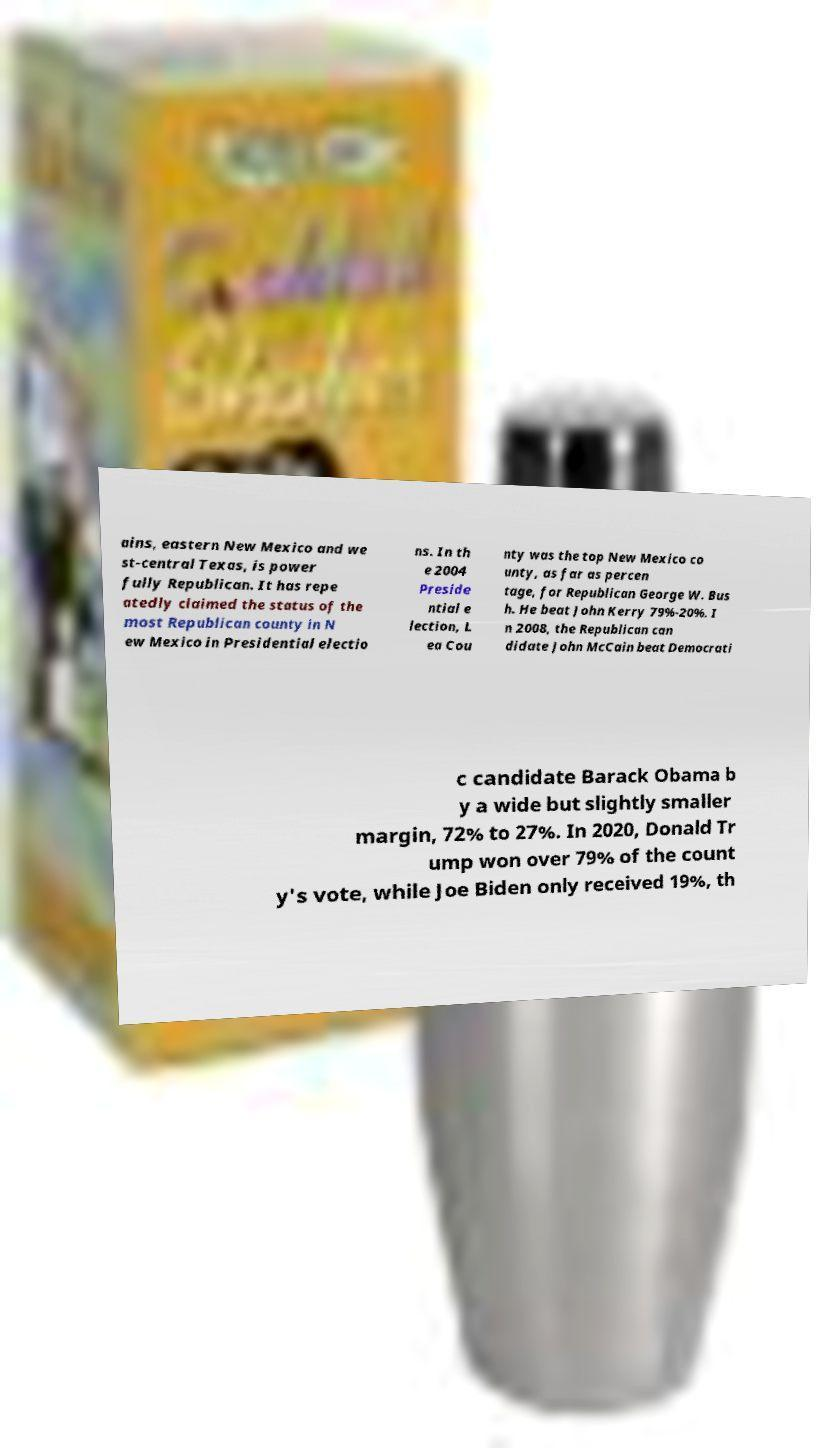Please identify and transcribe the text found in this image. ains, eastern New Mexico and we st-central Texas, is power fully Republican. It has repe atedly claimed the status of the most Republican county in N ew Mexico in Presidential electio ns. In th e 2004 Preside ntial e lection, L ea Cou nty was the top New Mexico co unty, as far as percen tage, for Republican George W. Bus h. He beat John Kerry 79%-20%. I n 2008, the Republican can didate John McCain beat Democrati c candidate Barack Obama b y a wide but slightly smaller margin, 72% to 27%. In 2020, Donald Tr ump won over 79% of the count y's vote, while Joe Biden only received 19%, th 